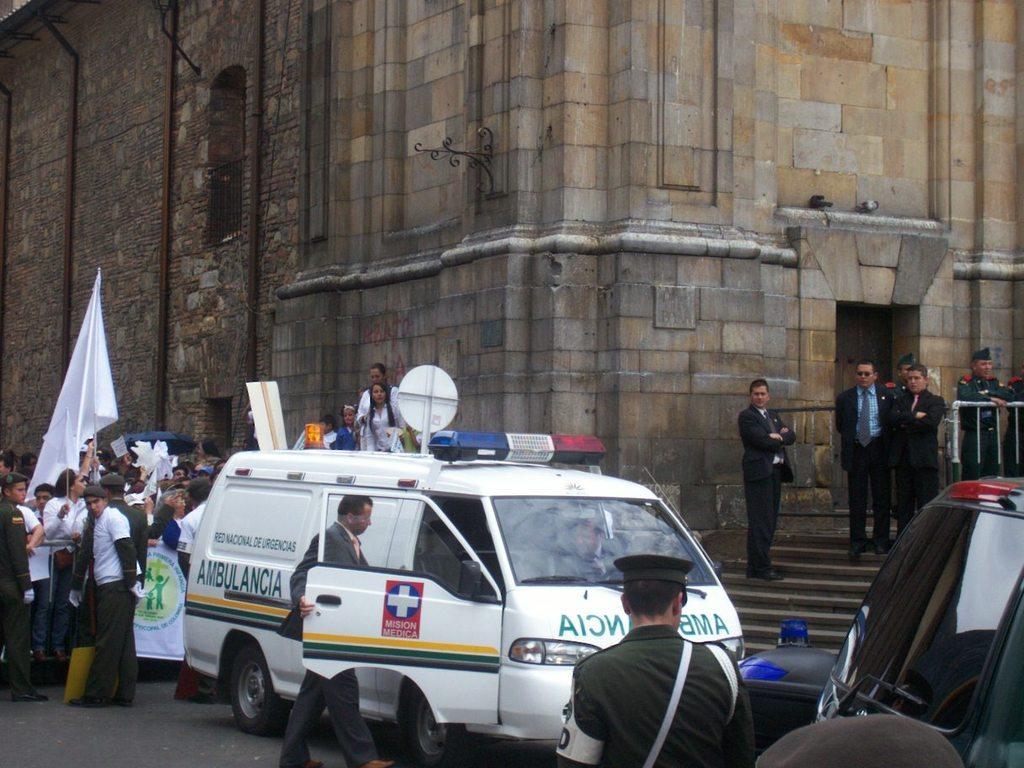Describe this image in one or two sentences. In this image we can see there are few vehicles and few people are walking and standing on the road, in them few are holding banners and flags, a few are standing on the stairs of a building. 